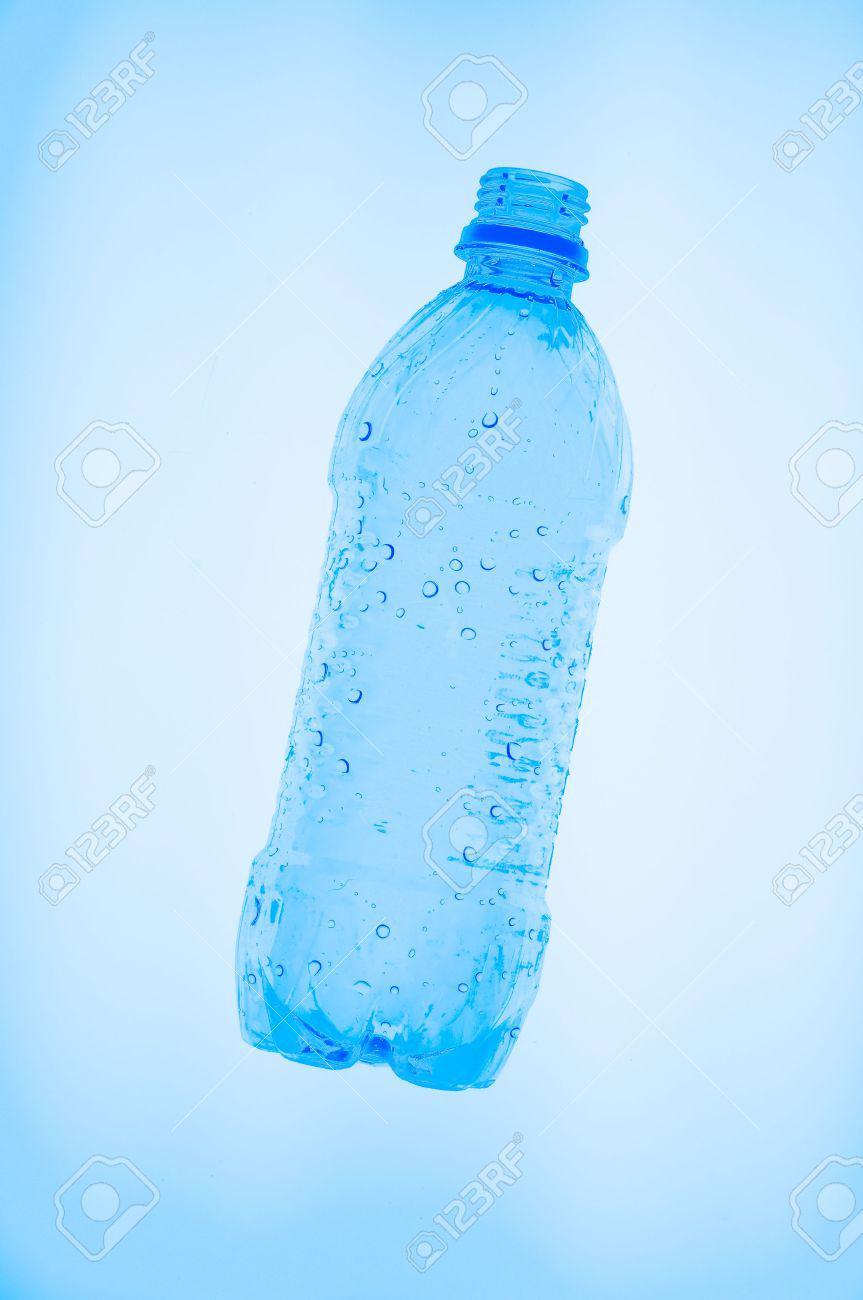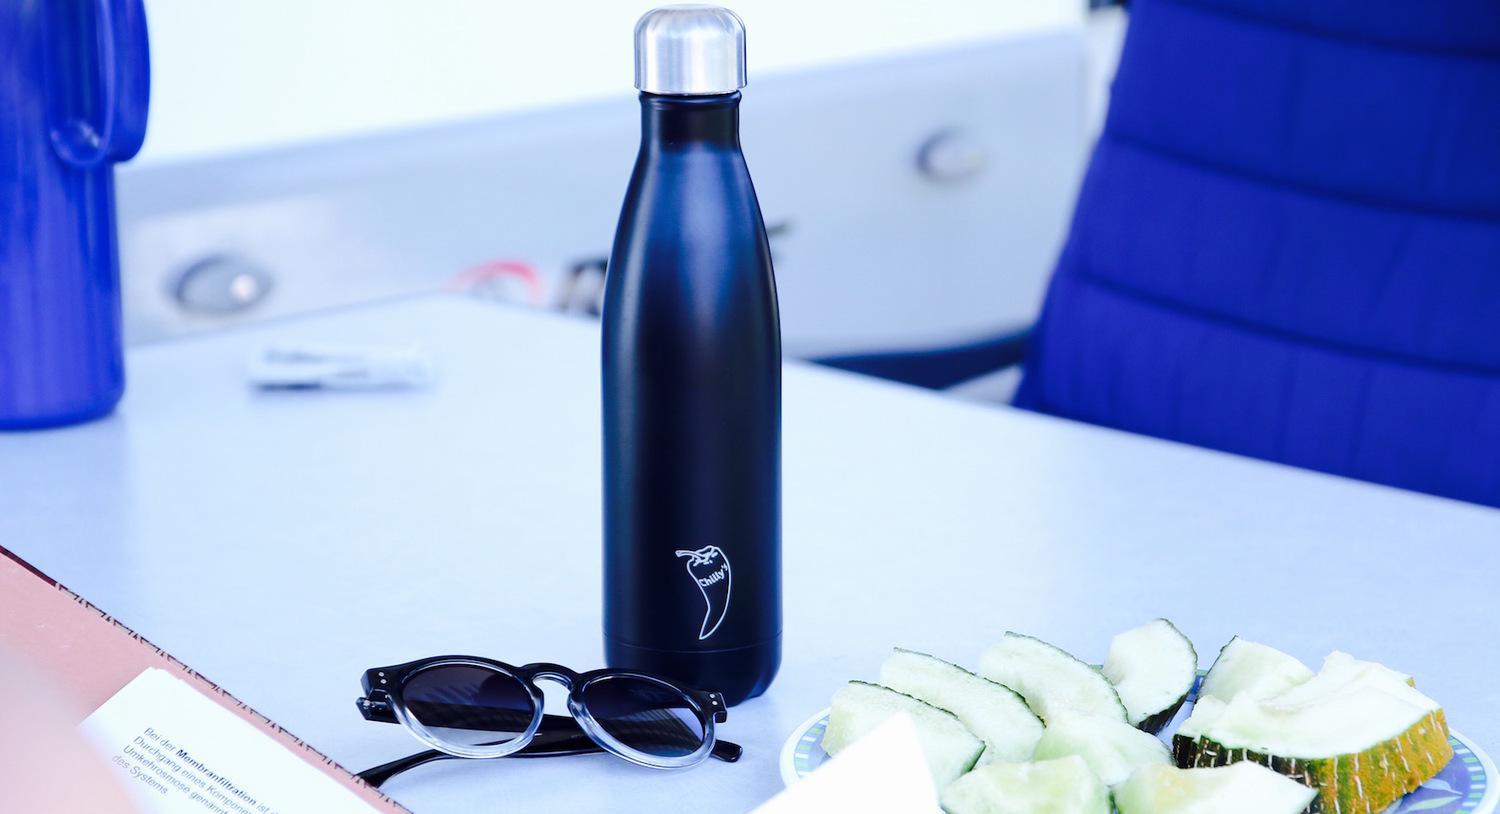The first image is the image on the left, the second image is the image on the right. Given the left and right images, does the statement "An image shows at least one stout translucent blue water jug with a lid on it." hold true? Answer yes or no. No. The first image is the image on the left, the second image is the image on the right. For the images shown, is this caption "At least one wide blue tinted bottle with a plastic cap is shown in one image, while a second image shows a personal water bottle with detachable cap." true? Answer yes or no. No. 